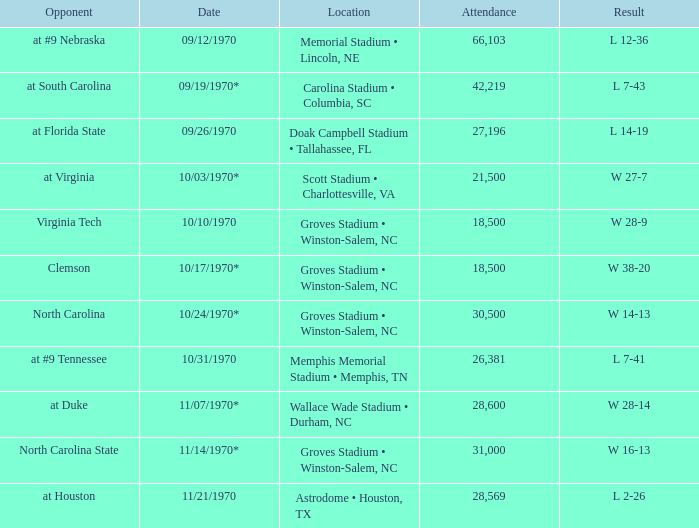How many people attended the game against Clemson? 1.0. 